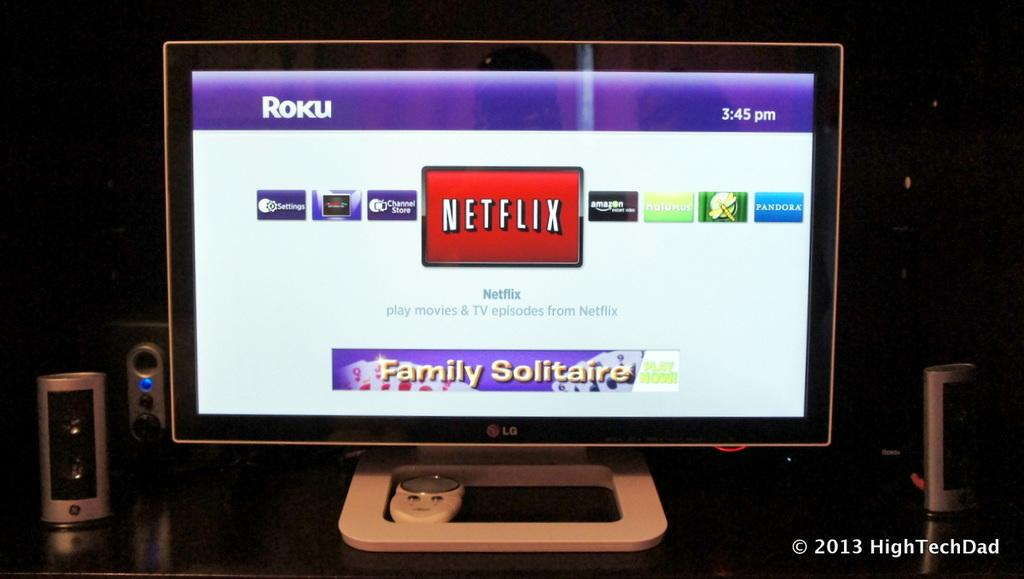<image>
Summarize the visual content of the image. A computer monitor shows Netflix being selected on the screen. 